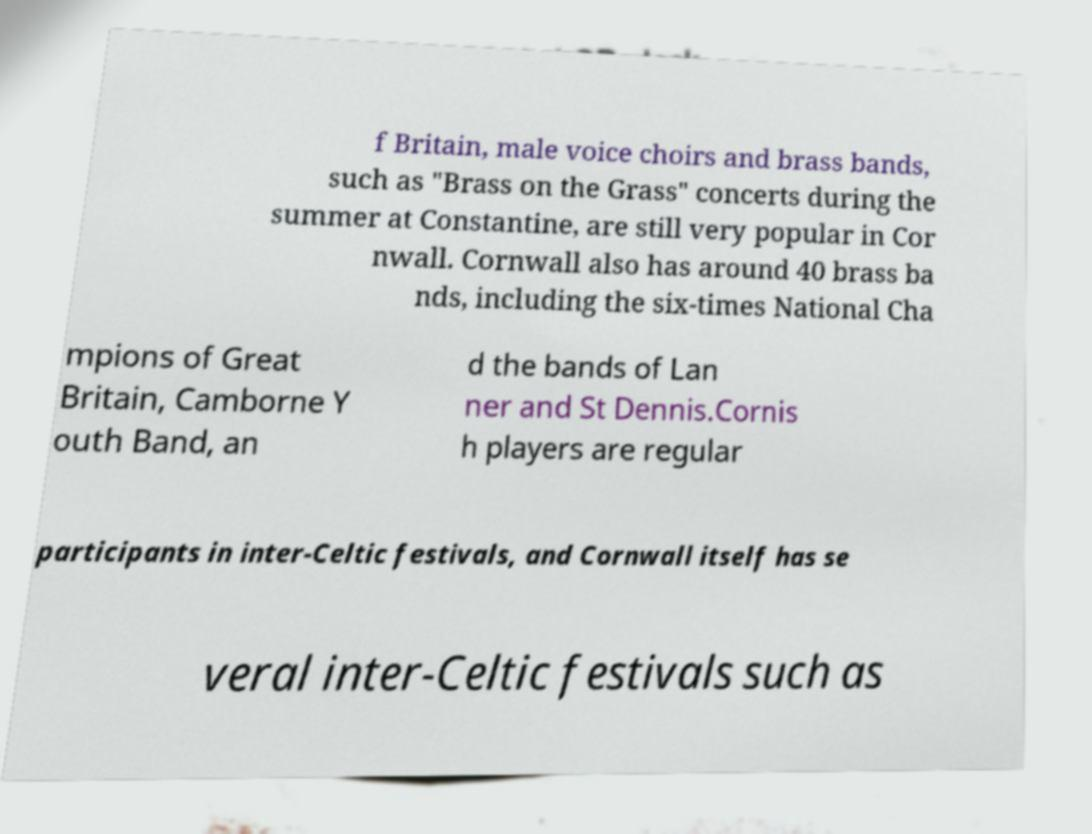Could you extract and type out the text from this image? f Britain, male voice choirs and brass bands, such as "Brass on the Grass" concerts during the summer at Constantine, are still very popular in Cor nwall. Cornwall also has around 40 brass ba nds, including the six-times National Cha mpions of Great Britain, Camborne Y outh Band, an d the bands of Lan ner and St Dennis.Cornis h players are regular participants in inter-Celtic festivals, and Cornwall itself has se veral inter-Celtic festivals such as 